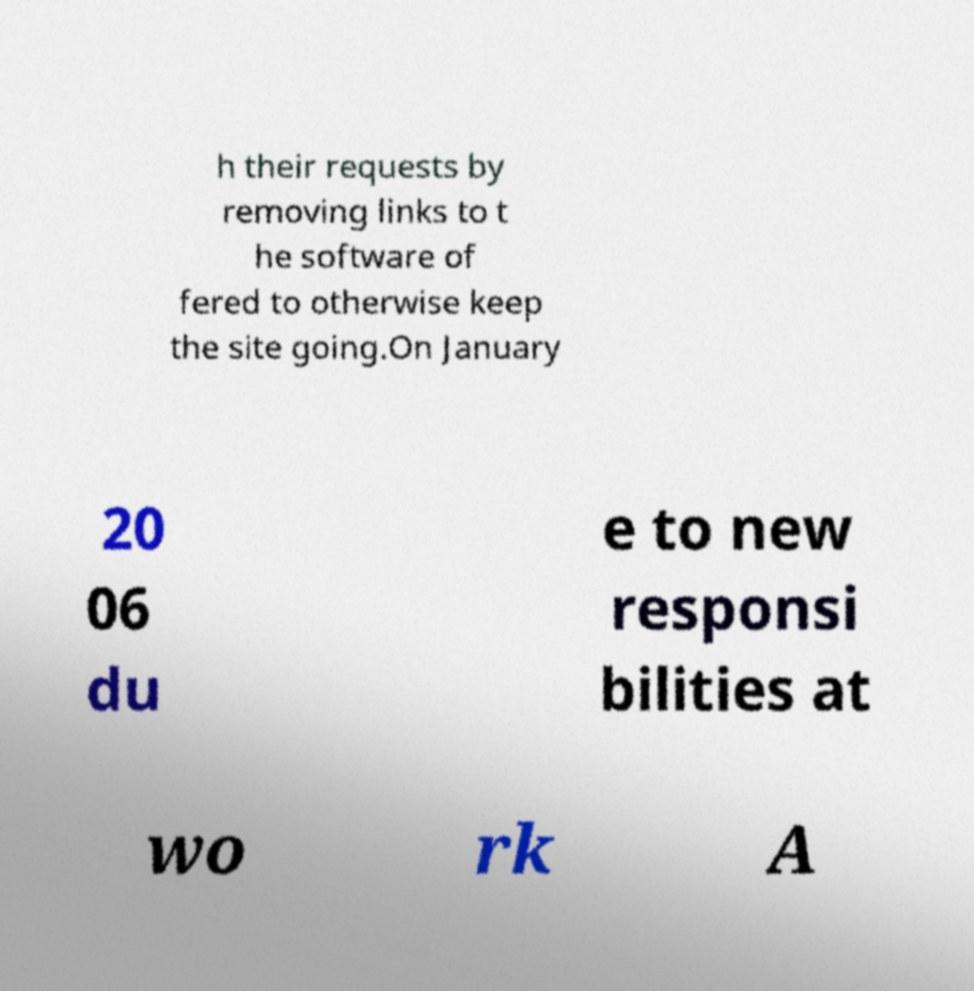Can you read and provide the text displayed in the image?This photo seems to have some interesting text. Can you extract and type it out for me? h their requests by removing links to t he software of fered to otherwise keep the site going.On January 20 06 du e to new responsi bilities at wo rk A 